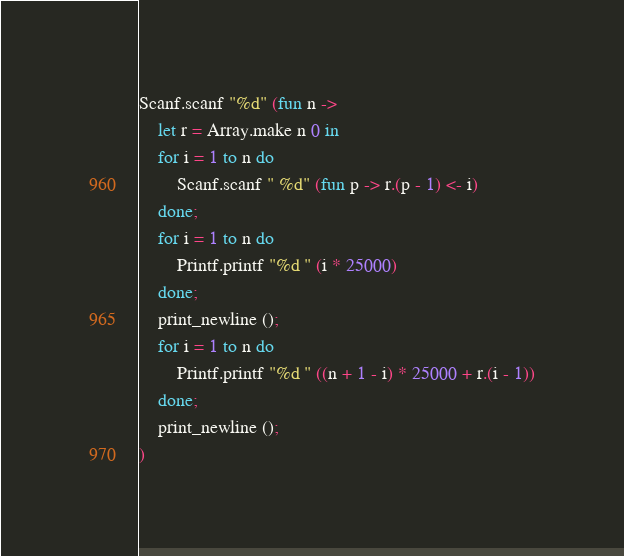Convert code to text. <code><loc_0><loc_0><loc_500><loc_500><_OCaml_>Scanf.scanf "%d" (fun n ->
    let r = Array.make n 0 in
    for i = 1 to n do
        Scanf.scanf " %d" (fun p -> r.(p - 1) <- i)
    done;
    for i = 1 to n do
        Printf.printf "%d " (i * 25000)
    done;
    print_newline ();
    for i = 1 to n do
        Printf.printf "%d " ((n + 1 - i) * 25000 + r.(i - 1))
    done;
    print_newline ();
)</code> 